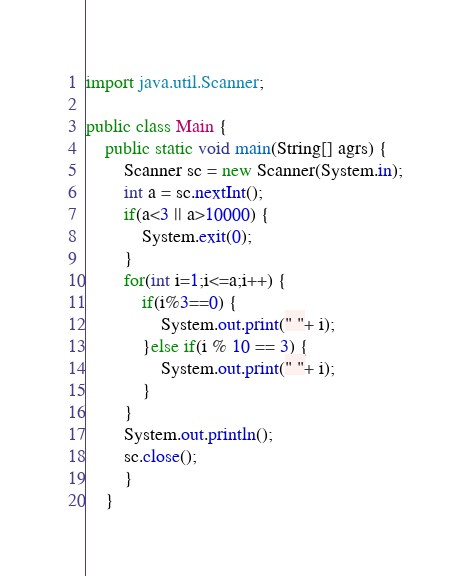Convert code to text. <code><loc_0><loc_0><loc_500><loc_500><_Java_>

import java.util.Scanner;

public class Main {
    public static void main(String[] agrs) {
    	Scanner sc = new Scanner(System.in);
    	int a = sc.nextInt();
    	if(a<3 || a>10000) {
    		System.exit(0);
    	}
    	for(int i=1;i<=a;i++) {
    		if(i%3==0) {
    			System.out.print(" "+ i);
    		}else if(i % 10 == 3) {
    			System.out.print(" "+ i);
    		}
    	}
    	System.out.println();
    	sc.close();
     	}
    }
</code> 